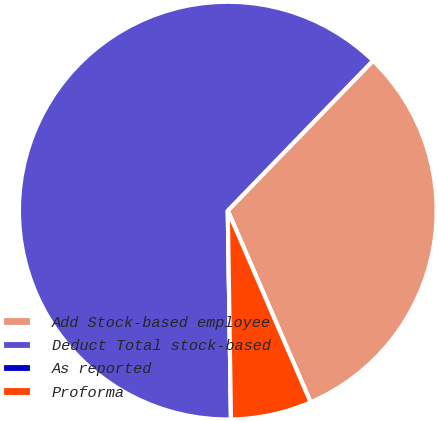<chart> <loc_0><loc_0><loc_500><loc_500><pie_chart><fcel>Add Stock-based employee<fcel>Deduct Total stock-based<fcel>As reported<fcel>Proforma<nl><fcel>31.26%<fcel>62.49%<fcel>0.0%<fcel>6.25%<nl></chart> 